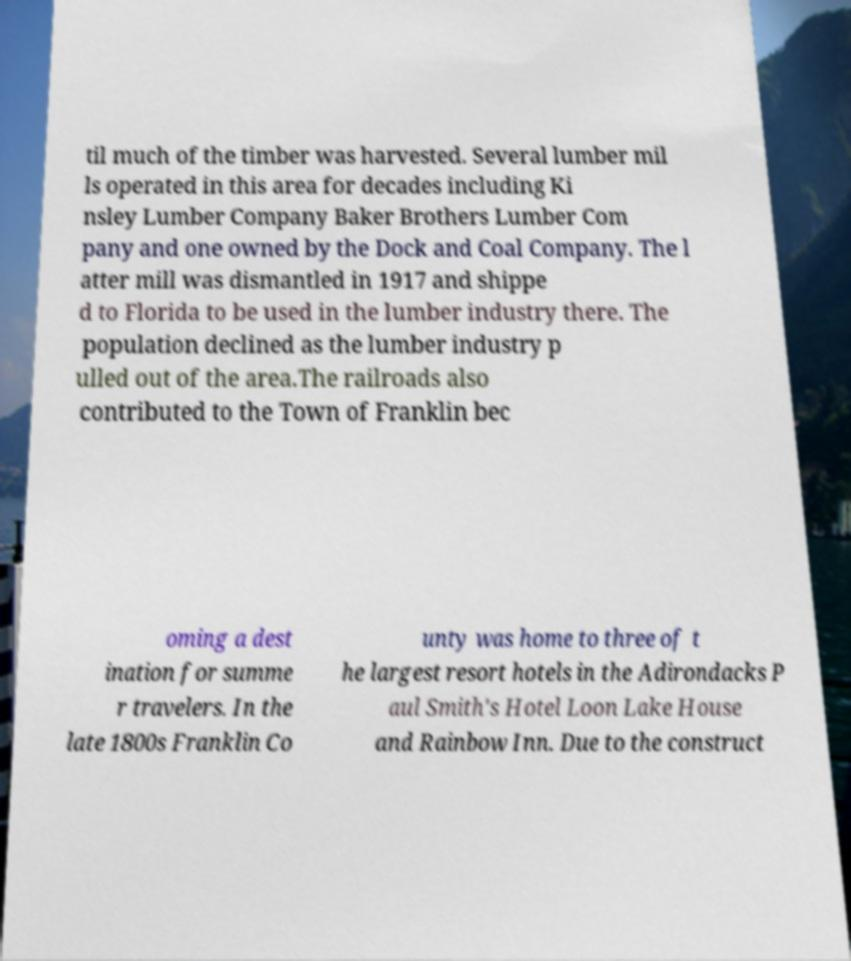Can you accurately transcribe the text from the provided image for me? til much of the timber was harvested. Several lumber mil ls operated in this area for decades including Ki nsley Lumber Company Baker Brothers Lumber Com pany and one owned by the Dock and Coal Company. The l atter mill was dismantled in 1917 and shippe d to Florida to be used in the lumber industry there. The population declined as the lumber industry p ulled out of the area.The railroads also contributed to the Town of Franklin bec oming a dest ination for summe r travelers. In the late 1800s Franklin Co unty was home to three of t he largest resort hotels in the Adirondacks P aul Smith's Hotel Loon Lake House and Rainbow Inn. Due to the construct 